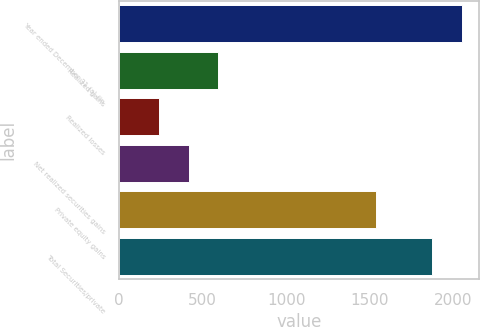Convert chart to OTSL. <chart><loc_0><loc_0><loc_500><loc_500><bar_chart><fcel>Year ended December 31 (a) (in<fcel>Realized gains<fcel>Realized losses<fcel>Net realized securities gains<fcel>Private equity gains<fcel>Total Securities/private<nl><fcel>2050.6<fcel>591.2<fcel>238<fcel>414.6<fcel>1536<fcel>1874<nl></chart> 